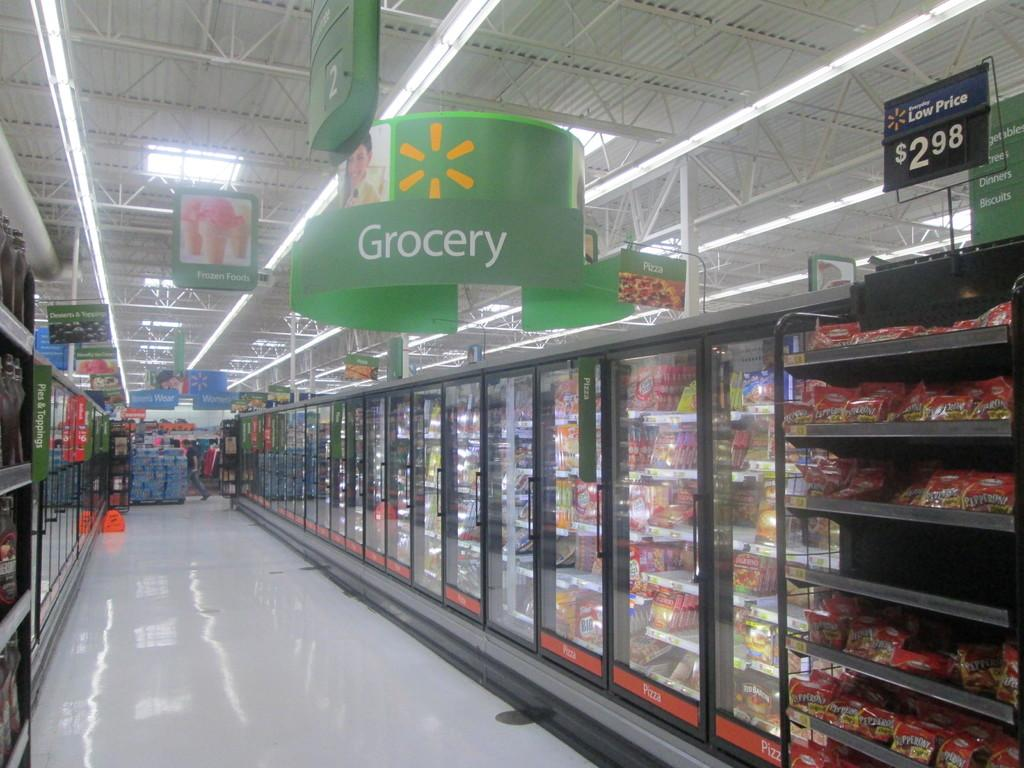<image>
Give a short and clear explanation of the subsequent image. store with refrigerated isle that has green sign at top that has grocery on it and rack toward front with price of 2.98 at top of it 